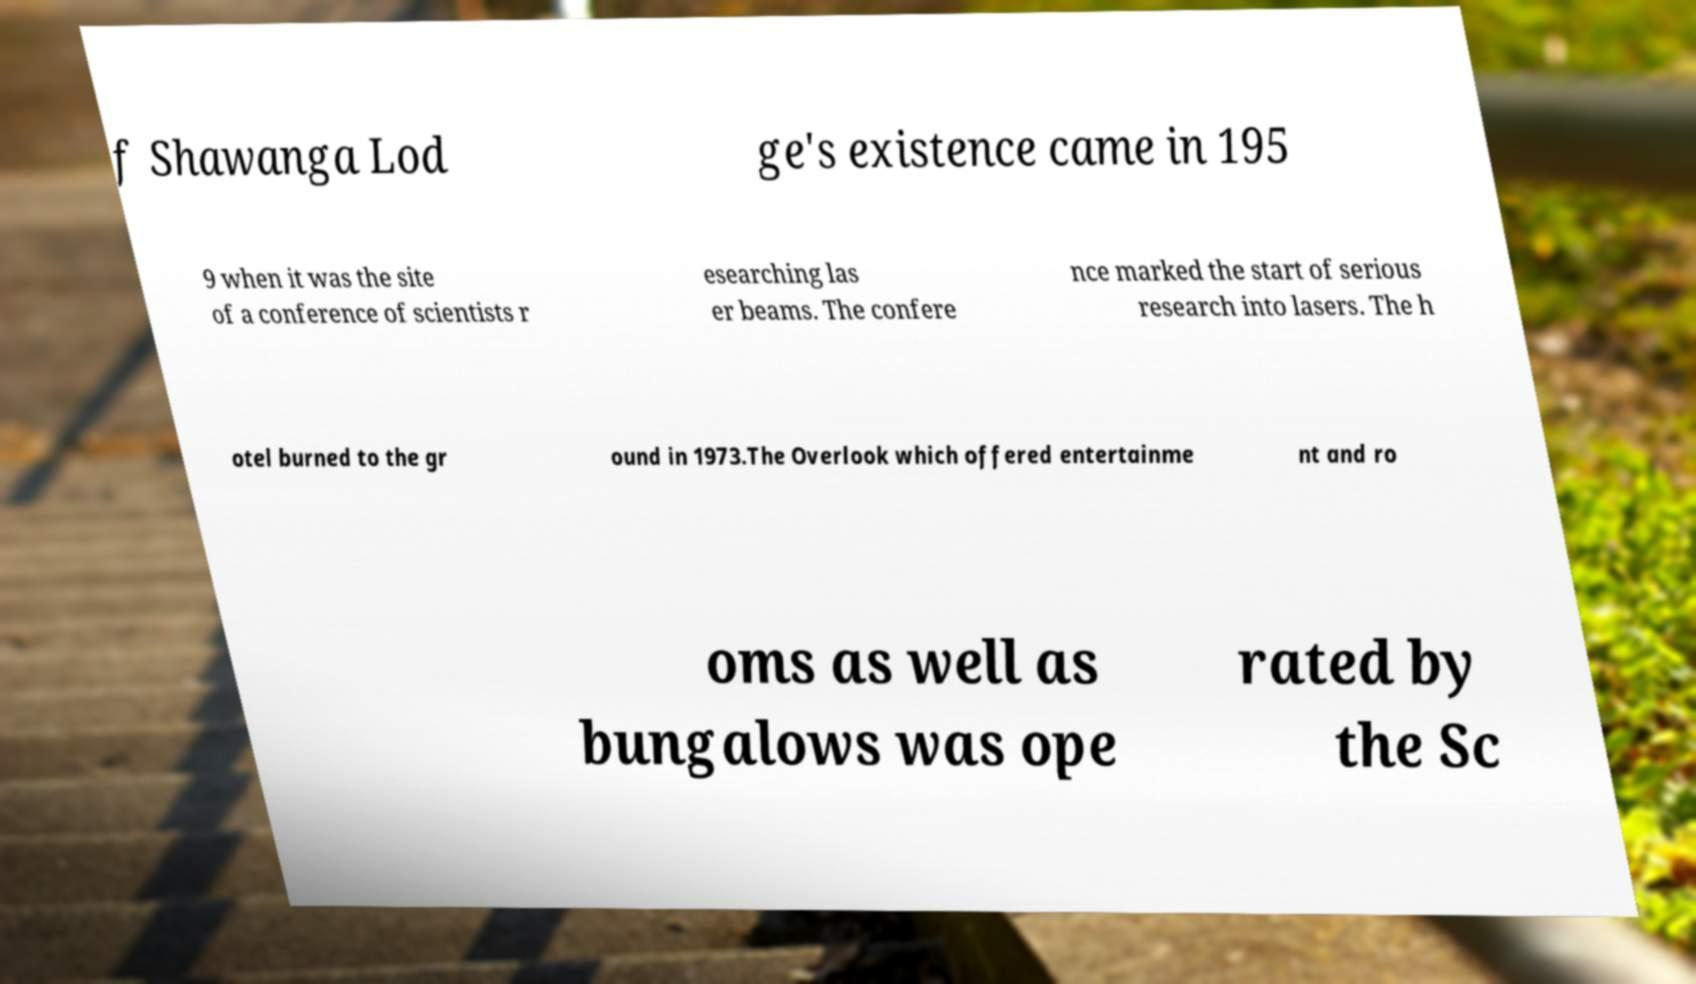Please read and relay the text visible in this image. What does it say? f Shawanga Lod ge's existence came in 195 9 when it was the site of a conference of scientists r esearching las er beams. The confere nce marked the start of serious research into lasers. The h otel burned to the gr ound in 1973.The Overlook which offered entertainme nt and ro oms as well as bungalows was ope rated by the Sc 